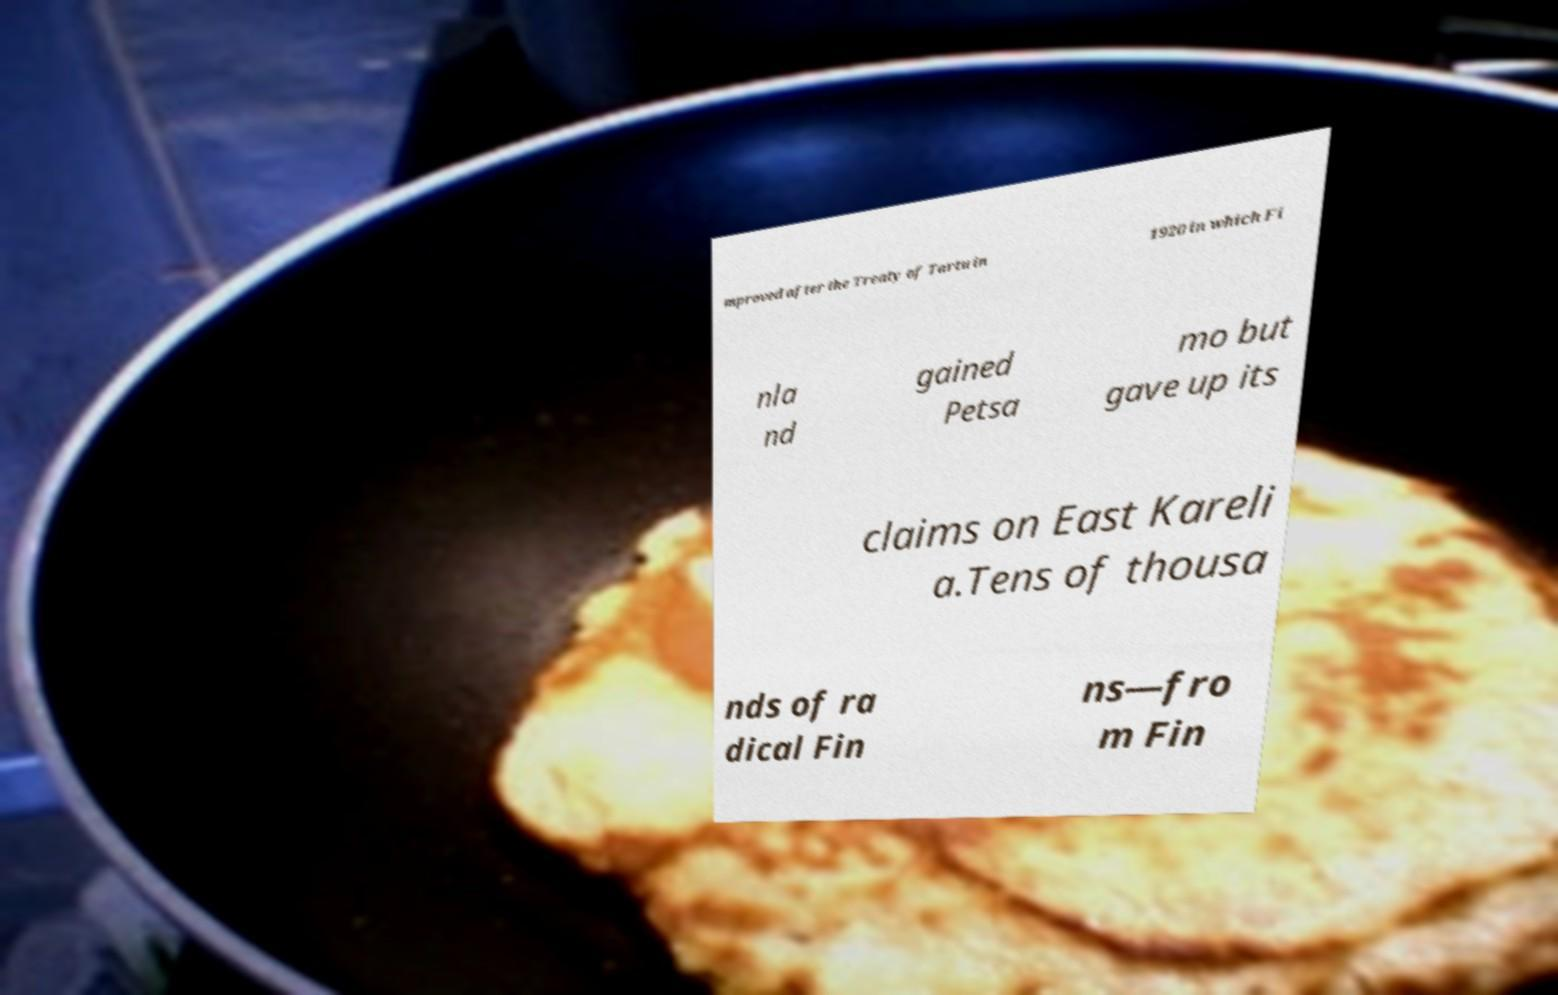Could you assist in decoding the text presented in this image and type it out clearly? mproved after the Treaty of Tartu in 1920 in which Fi nla nd gained Petsa mo but gave up its claims on East Kareli a.Tens of thousa nds of ra dical Fin ns—fro m Fin 